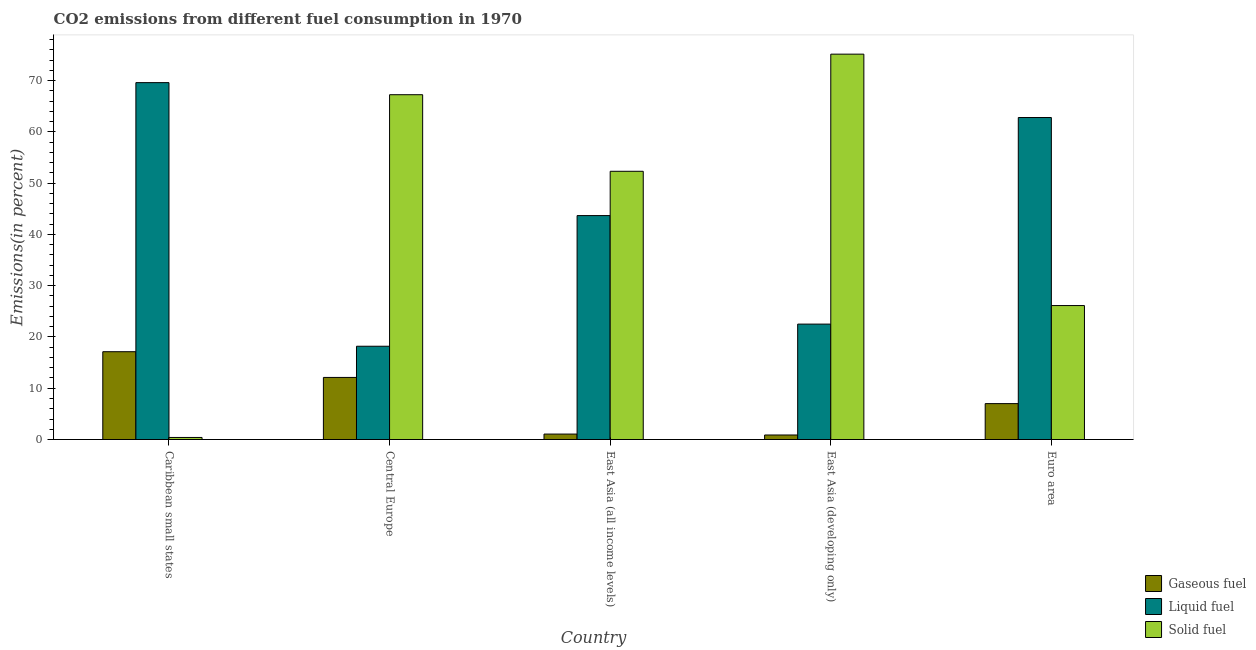How many different coloured bars are there?
Offer a terse response. 3. How many groups of bars are there?
Offer a terse response. 5. Are the number of bars per tick equal to the number of legend labels?
Your response must be concise. Yes. Are the number of bars on each tick of the X-axis equal?
Provide a short and direct response. Yes. How many bars are there on the 5th tick from the left?
Your answer should be compact. 3. What is the label of the 2nd group of bars from the left?
Ensure brevity in your answer.  Central Europe. In how many cases, is the number of bars for a given country not equal to the number of legend labels?
Provide a short and direct response. 0. What is the percentage of solid fuel emission in Caribbean small states?
Offer a terse response. 0.4. Across all countries, what is the maximum percentage of solid fuel emission?
Offer a terse response. 75.17. Across all countries, what is the minimum percentage of liquid fuel emission?
Offer a very short reply. 18.19. In which country was the percentage of gaseous fuel emission maximum?
Your answer should be compact. Caribbean small states. In which country was the percentage of gaseous fuel emission minimum?
Ensure brevity in your answer.  East Asia (developing only). What is the total percentage of liquid fuel emission in the graph?
Your answer should be very brief. 216.8. What is the difference between the percentage of solid fuel emission in Central Europe and that in East Asia (all income levels)?
Offer a terse response. 14.94. What is the difference between the percentage of gaseous fuel emission in Euro area and the percentage of liquid fuel emission in East Asia (developing only)?
Offer a terse response. -15.51. What is the average percentage of liquid fuel emission per country?
Keep it short and to the point. 43.36. What is the difference between the percentage of gaseous fuel emission and percentage of solid fuel emission in East Asia (all income levels)?
Provide a short and direct response. -51.26. In how many countries, is the percentage of solid fuel emission greater than 4 %?
Make the answer very short. 4. What is the ratio of the percentage of liquid fuel emission in Central Europe to that in Euro area?
Provide a succinct answer. 0.29. Is the percentage of solid fuel emission in Caribbean small states less than that in East Asia (developing only)?
Make the answer very short. Yes. What is the difference between the highest and the second highest percentage of gaseous fuel emission?
Provide a succinct answer. 5.02. What is the difference between the highest and the lowest percentage of liquid fuel emission?
Your response must be concise. 51.42. Is the sum of the percentage of gaseous fuel emission in Central Europe and Euro area greater than the maximum percentage of liquid fuel emission across all countries?
Offer a terse response. No. What does the 1st bar from the left in East Asia (all income levels) represents?
Offer a terse response. Gaseous fuel. What does the 2nd bar from the right in Caribbean small states represents?
Your answer should be compact. Liquid fuel. Is it the case that in every country, the sum of the percentage of gaseous fuel emission and percentage of liquid fuel emission is greater than the percentage of solid fuel emission?
Your response must be concise. No. How many bars are there?
Your response must be concise. 15. Are all the bars in the graph horizontal?
Offer a terse response. No. What is the difference between two consecutive major ticks on the Y-axis?
Your response must be concise. 10. Where does the legend appear in the graph?
Give a very brief answer. Bottom right. What is the title of the graph?
Make the answer very short. CO2 emissions from different fuel consumption in 1970. Does "Male employers" appear as one of the legend labels in the graph?
Ensure brevity in your answer.  No. What is the label or title of the Y-axis?
Ensure brevity in your answer.  Emissions(in percent). What is the Emissions(in percent) of Gaseous fuel in Caribbean small states?
Ensure brevity in your answer.  17.13. What is the Emissions(in percent) in Liquid fuel in Caribbean small states?
Give a very brief answer. 69.61. What is the Emissions(in percent) of Solid fuel in Caribbean small states?
Your response must be concise. 0.4. What is the Emissions(in percent) in Gaseous fuel in Central Europe?
Provide a succinct answer. 12.11. What is the Emissions(in percent) in Liquid fuel in Central Europe?
Your answer should be very brief. 18.19. What is the Emissions(in percent) of Solid fuel in Central Europe?
Provide a short and direct response. 67.25. What is the Emissions(in percent) in Gaseous fuel in East Asia (all income levels)?
Your answer should be compact. 1.06. What is the Emissions(in percent) of Liquid fuel in East Asia (all income levels)?
Keep it short and to the point. 43.68. What is the Emissions(in percent) of Solid fuel in East Asia (all income levels)?
Provide a short and direct response. 52.32. What is the Emissions(in percent) in Gaseous fuel in East Asia (developing only)?
Ensure brevity in your answer.  0.88. What is the Emissions(in percent) of Liquid fuel in East Asia (developing only)?
Offer a very short reply. 22.51. What is the Emissions(in percent) of Solid fuel in East Asia (developing only)?
Provide a short and direct response. 75.17. What is the Emissions(in percent) in Gaseous fuel in Euro area?
Keep it short and to the point. 7. What is the Emissions(in percent) of Liquid fuel in Euro area?
Make the answer very short. 62.81. What is the Emissions(in percent) in Solid fuel in Euro area?
Your answer should be compact. 26.13. Across all countries, what is the maximum Emissions(in percent) of Gaseous fuel?
Ensure brevity in your answer.  17.13. Across all countries, what is the maximum Emissions(in percent) of Liquid fuel?
Your answer should be compact. 69.61. Across all countries, what is the maximum Emissions(in percent) in Solid fuel?
Provide a short and direct response. 75.17. Across all countries, what is the minimum Emissions(in percent) in Gaseous fuel?
Ensure brevity in your answer.  0.88. Across all countries, what is the minimum Emissions(in percent) of Liquid fuel?
Your answer should be very brief. 18.19. Across all countries, what is the minimum Emissions(in percent) in Solid fuel?
Your answer should be compact. 0.4. What is the total Emissions(in percent) in Gaseous fuel in the graph?
Make the answer very short. 38.19. What is the total Emissions(in percent) of Liquid fuel in the graph?
Provide a short and direct response. 216.8. What is the total Emissions(in percent) of Solid fuel in the graph?
Give a very brief answer. 221.27. What is the difference between the Emissions(in percent) of Gaseous fuel in Caribbean small states and that in Central Europe?
Give a very brief answer. 5.02. What is the difference between the Emissions(in percent) of Liquid fuel in Caribbean small states and that in Central Europe?
Your answer should be very brief. 51.42. What is the difference between the Emissions(in percent) of Solid fuel in Caribbean small states and that in Central Europe?
Your answer should be compact. -66.85. What is the difference between the Emissions(in percent) of Gaseous fuel in Caribbean small states and that in East Asia (all income levels)?
Provide a short and direct response. 16.07. What is the difference between the Emissions(in percent) in Liquid fuel in Caribbean small states and that in East Asia (all income levels)?
Offer a very short reply. 25.93. What is the difference between the Emissions(in percent) in Solid fuel in Caribbean small states and that in East Asia (all income levels)?
Make the answer very short. -51.92. What is the difference between the Emissions(in percent) in Gaseous fuel in Caribbean small states and that in East Asia (developing only)?
Give a very brief answer. 16.24. What is the difference between the Emissions(in percent) of Liquid fuel in Caribbean small states and that in East Asia (developing only)?
Provide a succinct answer. 47.1. What is the difference between the Emissions(in percent) of Solid fuel in Caribbean small states and that in East Asia (developing only)?
Your response must be concise. -74.76. What is the difference between the Emissions(in percent) of Gaseous fuel in Caribbean small states and that in Euro area?
Keep it short and to the point. 10.12. What is the difference between the Emissions(in percent) of Liquid fuel in Caribbean small states and that in Euro area?
Provide a short and direct response. 6.81. What is the difference between the Emissions(in percent) of Solid fuel in Caribbean small states and that in Euro area?
Offer a very short reply. -25.73. What is the difference between the Emissions(in percent) in Gaseous fuel in Central Europe and that in East Asia (all income levels)?
Your response must be concise. 11.05. What is the difference between the Emissions(in percent) of Liquid fuel in Central Europe and that in East Asia (all income levels)?
Your answer should be compact. -25.48. What is the difference between the Emissions(in percent) in Solid fuel in Central Europe and that in East Asia (all income levels)?
Make the answer very short. 14.94. What is the difference between the Emissions(in percent) of Gaseous fuel in Central Europe and that in East Asia (developing only)?
Your answer should be compact. 11.23. What is the difference between the Emissions(in percent) of Liquid fuel in Central Europe and that in East Asia (developing only)?
Your answer should be compact. -4.32. What is the difference between the Emissions(in percent) in Solid fuel in Central Europe and that in East Asia (developing only)?
Your answer should be very brief. -7.91. What is the difference between the Emissions(in percent) of Gaseous fuel in Central Europe and that in Euro area?
Keep it short and to the point. 5.11. What is the difference between the Emissions(in percent) in Liquid fuel in Central Europe and that in Euro area?
Provide a short and direct response. -44.61. What is the difference between the Emissions(in percent) in Solid fuel in Central Europe and that in Euro area?
Your answer should be compact. 41.13. What is the difference between the Emissions(in percent) of Gaseous fuel in East Asia (all income levels) and that in East Asia (developing only)?
Offer a very short reply. 0.18. What is the difference between the Emissions(in percent) of Liquid fuel in East Asia (all income levels) and that in East Asia (developing only)?
Make the answer very short. 21.17. What is the difference between the Emissions(in percent) of Solid fuel in East Asia (all income levels) and that in East Asia (developing only)?
Your answer should be compact. -22.85. What is the difference between the Emissions(in percent) of Gaseous fuel in East Asia (all income levels) and that in Euro area?
Your answer should be compact. -5.94. What is the difference between the Emissions(in percent) of Liquid fuel in East Asia (all income levels) and that in Euro area?
Ensure brevity in your answer.  -19.13. What is the difference between the Emissions(in percent) in Solid fuel in East Asia (all income levels) and that in Euro area?
Provide a succinct answer. 26.19. What is the difference between the Emissions(in percent) of Gaseous fuel in East Asia (developing only) and that in Euro area?
Keep it short and to the point. -6.12. What is the difference between the Emissions(in percent) in Liquid fuel in East Asia (developing only) and that in Euro area?
Make the answer very short. -40.3. What is the difference between the Emissions(in percent) of Solid fuel in East Asia (developing only) and that in Euro area?
Ensure brevity in your answer.  49.04. What is the difference between the Emissions(in percent) in Gaseous fuel in Caribbean small states and the Emissions(in percent) in Liquid fuel in Central Europe?
Your answer should be very brief. -1.07. What is the difference between the Emissions(in percent) of Gaseous fuel in Caribbean small states and the Emissions(in percent) of Solid fuel in Central Europe?
Your answer should be compact. -50.13. What is the difference between the Emissions(in percent) of Liquid fuel in Caribbean small states and the Emissions(in percent) of Solid fuel in Central Europe?
Give a very brief answer. 2.36. What is the difference between the Emissions(in percent) of Gaseous fuel in Caribbean small states and the Emissions(in percent) of Liquid fuel in East Asia (all income levels)?
Provide a succinct answer. -26.55. What is the difference between the Emissions(in percent) of Gaseous fuel in Caribbean small states and the Emissions(in percent) of Solid fuel in East Asia (all income levels)?
Your response must be concise. -35.19. What is the difference between the Emissions(in percent) of Liquid fuel in Caribbean small states and the Emissions(in percent) of Solid fuel in East Asia (all income levels)?
Keep it short and to the point. 17.29. What is the difference between the Emissions(in percent) in Gaseous fuel in Caribbean small states and the Emissions(in percent) in Liquid fuel in East Asia (developing only)?
Offer a terse response. -5.38. What is the difference between the Emissions(in percent) of Gaseous fuel in Caribbean small states and the Emissions(in percent) of Solid fuel in East Asia (developing only)?
Keep it short and to the point. -58.04. What is the difference between the Emissions(in percent) of Liquid fuel in Caribbean small states and the Emissions(in percent) of Solid fuel in East Asia (developing only)?
Provide a short and direct response. -5.56. What is the difference between the Emissions(in percent) in Gaseous fuel in Caribbean small states and the Emissions(in percent) in Liquid fuel in Euro area?
Offer a terse response. -45.68. What is the difference between the Emissions(in percent) in Gaseous fuel in Caribbean small states and the Emissions(in percent) in Solid fuel in Euro area?
Keep it short and to the point. -9. What is the difference between the Emissions(in percent) of Liquid fuel in Caribbean small states and the Emissions(in percent) of Solid fuel in Euro area?
Provide a succinct answer. 43.48. What is the difference between the Emissions(in percent) of Gaseous fuel in Central Europe and the Emissions(in percent) of Liquid fuel in East Asia (all income levels)?
Your answer should be very brief. -31.57. What is the difference between the Emissions(in percent) in Gaseous fuel in Central Europe and the Emissions(in percent) in Solid fuel in East Asia (all income levels)?
Give a very brief answer. -40.21. What is the difference between the Emissions(in percent) in Liquid fuel in Central Europe and the Emissions(in percent) in Solid fuel in East Asia (all income levels)?
Ensure brevity in your answer.  -34.12. What is the difference between the Emissions(in percent) in Gaseous fuel in Central Europe and the Emissions(in percent) in Liquid fuel in East Asia (developing only)?
Provide a short and direct response. -10.4. What is the difference between the Emissions(in percent) of Gaseous fuel in Central Europe and the Emissions(in percent) of Solid fuel in East Asia (developing only)?
Your answer should be compact. -63.06. What is the difference between the Emissions(in percent) in Liquid fuel in Central Europe and the Emissions(in percent) in Solid fuel in East Asia (developing only)?
Ensure brevity in your answer.  -56.97. What is the difference between the Emissions(in percent) in Gaseous fuel in Central Europe and the Emissions(in percent) in Liquid fuel in Euro area?
Your response must be concise. -50.7. What is the difference between the Emissions(in percent) in Gaseous fuel in Central Europe and the Emissions(in percent) in Solid fuel in Euro area?
Make the answer very short. -14.02. What is the difference between the Emissions(in percent) of Liquid fuel in Central Europe and the Emissions(in percent) of Solid fuel in Euro area?
Offer a terse response. -7.94. What is the difference between the Emissions(in percent) in Gaseous fuel in East Asia (all income levels) and the Emissions(in percent) in Liquid fuel in East Asia (developing only)?
Make the answer very short. -21.45. What is the difference between the Emissions(in percent) of Gaseous fuel in East Asia (all income levels) and the Emissions(in percent) of Solid fuel in East Asia (developing only)?
Your response must be concise. -74.11. What is the difference between the Emissions(in percent) in Liquid fuel in East Asia (all income levels) and the Emissions(in percent) in Solid fuel in East Asia (developing only)?
Keep it short and to the point. -31.49. What is the difference between the Emissions(in percent) in Gaseous fuel in East Asia (all income levels) and the Emissions(in percent) in Liquid fuel in Euro area?
Ensure brevity in your answer.  -61.74. What is the difference between the Emissions(in percent) of Gaseous fuel in East Asia (all income levels) and the Emissions(in percent) of Solid fuel in Euro area?
Your answer should be compact. -25.07. What is the difference between the Emissions(in percent) in Liquid fuel in East Asia (all income levels) and the Emissions(in percent) in Solid fuel in Euro area?
Keep it short and to the point. 17.55. What is the difference between the Emissions(in percent) of Gaseous fuel in East Asia (developing only) and the Emissions(in percent) of Liquid fuel in Euro area?
Keep it short and to the point. -61.92. What is the difference between the Emissions(in percent) in Gaseous fuel in East Asia (developing only) and the Emissions(in percent) in Solid fuel in Euro area?
Ensure brevity in your answer.  -25.25. What is the difference between the Emissions(in percent) of Liquid fuel in East Asia (developing only) and the Emissions(in percent) of Solid fuel in Euro area?
Keep it short and to the point. -3.62. What is the average Emissions(in percent) in Gaseous fuel per country?
Your answer should be very brief. 7.64. What is the average Emissions(in percent) in Liquid fuel per country?
Your response must be concise. 43.36. What is the average Emissions(in percent) of Solid fuel per country?
Offer a terse response. 44.25. What is the difference between the Emissions(in percent) of Gaseous fuel and Emissions(in percent) of Liquid fuel in Caribbean small states?
Keep it short and to the point. -52.48. What is the difference between the Emissions(in percent) of Gaseous fuel and Emissions(in percent) of Solid fuel in Caribbean small states?
Offer a very short reply. 16.73. What is the difference between the Emissions(in percent) of Liquid fuel and Emissions(in percent) of Solid fuel in Caribbean small states?
Keep it short and to the point. 69.21. What is the difference between the Emissions(in percent) of Gaseous fuel and Emissions(in percent) of Liquid fuel in Central Europe?
Keep it short and to the point. -6.08. What is the difference between the Emissions(in percent) of Gaseous fuel and Emissions(in percent) of Solid fuel in Central Europe?
Your answer should be compact. -55.14. What is the difference between the Emissions(in percent) of Liquid fuel and Emissions(in percent) of Solid fuel in Central Europe?
Ensure brevity in your answer.  -49.06. What is the difference between the Emissions(in percent) in Gaseous fuel and Emissions(in percent) in Liquid fuel in East Asia (all income levels)?
Offer a terse response. -42.62. What is the difference between the Emissions(in percent) in Gaseous fuel and Emissions(in percent) in Solid fuel in East Asia (all income levels)?
Offer a terse response. -51.26. What is the difference between the Emissions(in percent) of Liquid fuel and Emissions(in percent) of Solid fuel in East Asia (all income levels)?
Your answer should be very brief. -8.64. What is the difference between the Emissions(in percent) in Gaseous fuel and Emissions(in percent) in Liquid fuel in East Asia (developing only)?
Make the answer very short. -21.63. What is the difference between the Emissions(in percent) of Gaseous fuel and Emissions(in percent) of Solid fuel in East Asia (developing only)?
Your response must be concise. -74.28. What is the difference between the Emissions(in percent) of Liquid fuel and Emissions(in percent) of Solid fuel in East Asia (developing only)?
Your answer should be compact. -52.66. What is the difference between the Emissions(in percent) of Gaseous fuel and Emissions(in percent) of Liquid fuel in Euro area?
Your answer should be very brief. -55.8. What is the difference between the Emissions(in percent) in Gaseous fuel and Emissions(in percent) in Solid fuel in Euro area?
Keep it short and to the point. -19.13. What is the difference between the Emissions(in percent) in Liquid fuel and Emissions(in percent) in Solid fuel in Euro area?
Your answer should be very brief. 36.68. What is the ratio of the Emissions(in percent) in Gaseous fuel in Caribbean small states to that in Central Europe?
Offer a very short reply. 1.41. What is the ratio of the Emissions(in percent) of Liquid fuel in Caribbean small states to that in Central Europe?
Make the answer very short. 3.83. What is the ratio of the Emissions(in percent) of Solid fuel in Caribbean small states to that in Central Europe?
Provide a succinct answer. 0.01. What is the ratio of the Emissions(in percent) in Gaseous fuel in Caribbean small states to that in East Asia (all income levels)?
Provide a short and direct response. 16.13. What is the ratio of the Emissions(in percent) in Liquid fuel in Caribbean small states to that in East Asia (all income levels)?
Ensure brevity in your answer.  1.59. What is the ratio of the Emissions(in percent) in Solid fuel in Caribbean small states to that in East Asia (all income levels)?
Keep it short and to the point. 0.01. What is the ratio of the Emissions(in percent) of Gaseous fuel in Caribbean small states to that in East Asia (developing only)?
Keep it short and to the point. 19.38. What is the ratio of the Emissions(in percent) in Liquid fuel in Caribbean small states to that in East Asia (developing only)?
Your answer should be compact. 3.09. What is the ratio of the Emissions(in percent) in Solid fuel in Caribbean small states to that in East Asia (developing only)?
Keep it short and to the point. 0.01. What is the ratio of the Emissions(in percent) in Gaseous fuel in Caribbean small states to that in Euro area?
Your answer should be compact. 2.45. What is the ratio of the Emissions(in percent) of Liquid fuel in Caribbean small states to that in Euro area?
Provide a short and direct response. 1.11. What is the ratio of the Emissions(in percent) of Solid fuel in Caribbean small states to that in Euro area?
Ensure brevity in your answer.  0.02. What is the ratio of the Emissions(in percent) of Gaseous fuel in Central Europe to that in East Asia (all income levels)?
Make the answer very short. 11.41. What is the ratio of the Emissions(in percent) of Liquid fuel in Central Europe to that in East Asia (all income levels)?
Provide a short and direct response. 0.42. What is the ratio of the Emissions(in percent) of Solid fuel in Central Europe to that in East Asia (all income levels)?
Provide a succinct answer. 1.29. What is the ratio of the Emissions(in percent) of Gaseous fuel in Central Europe to that in East Asia (developing only)?
Your answer should be very brief. 13.7. What is the ratio of the Emissions(in percent) in Liquid fuel in Central Europe to that in East Asia (developing only)?
Provide a short and direct response. 0.81. What is the ratio of the Emissions(in percent) in Solid fuel in Central Europe to that in East Asia (developing only)?
Your answer should be very brief. 0.89. What is the ratio of the Emissions(in percent) in Gaseous fuel in Central Europe to that in Euro area?
Your answer should be compact. 1.73. What is the ratio of the Emissions(in percent) of Liquid fuel in Central Europe to that in Euro area?
Your answer should be very brief. 0.29. What is the ratio of the Emissions(in percent) of Solid fuel in Central Europe to that in Euro area?
Make the answer very short. 2.57. What is the ratio of the Emissions(in percent) in Gaseous fuel in East Asia (all income levels) to that in East Asia (developing only)?
Give a very brief answer. 1.2. What is the ratio of the Emissions(in percent) in Liquid fuel in East Asia (all income levels) to that in East Asia (developing only)?
Your response must be concise. 1.94. What is the ratio of the Emissions(in percent) in Solid fuel in East Asia (all income levels) to that in East Asia (developing only)?
Make the answer very short. 0.7. What is the ratio of the Emissions(in percent) of Gaseous fuel in East Asia (all income levels) to that in Euro area?
Offer a very short reply. 0.15. What is the ratio of the Emissions(in percent) of Liquid fuel in East Asia (all income levels) to that in Euro area?
Your answer should be very brief. 0.7. What is the ratio of the Emissions(in percent) in Solid fuel in East Asia (all income levels) to that in Euro area?
Make the answer very short. 2. What is the ratio of the Emissions(in percent) of Gaseous fuel in East Asia (developing only) to that in Euro area?
Offer a very short reply. 0.13. What is the ratio of the Emissions(in percent) of Liquid fuel in East Asia (developing only) to that in Euro area?
Provide a short and direct response. 0.36. What is the ratio of the Emissions(in percent) in Solid fuel in East Asia (developing only) to that in Euro area?
Provide a succinct answer. 2.88. What is the difference between the highest and the second highest Emissions(in percent) of Gaseous fuel?
Your answer should be compact. 5.02. What is the difference between the highest and the second highest Emissions(in percent) of Liquid fuel?
Offer a terse response. 6.81. What is the difference between the highest and the second highest Emissions(in percent) of Solid fuel?
Provide a short and direct response. 7.91. What is the difference between the highest and the lowest Emissions(in percent) of Gaseous fuel?
Make the answer very short. 16.24. What is the difference between the highest and the lowest Emissions(in percent) in Liquid fuel?
Make the answer very short. 51.42. What is the difference between the highest and the lowest Emissions(in percent) in Solid fuel?
Your answer should be compact. 74.76. 